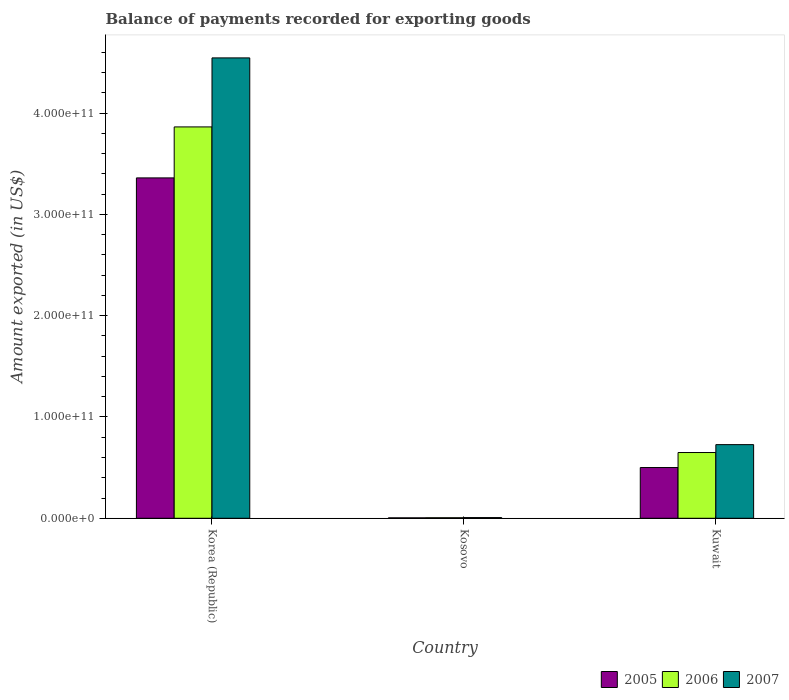Are the number of bars per tick equal to the number of legend labels?
Offer a very short reply. Yes. In how many cases, is the number of bars for a given country not equal to the number of legend labels?
Give a very brief answer. 0. What is the amount exported in 2005 in Korea (Republic)?
Offer a very short reply. 3.36e+11. Across all countries, what is the maximum amount exported in 2005?
Your response must be concise. 3.36e+11. Across all countries, what is the minimum amount exported in 2005?
Provide a short and direct response. 4.13e+08. In which country was the amount exported in 2005 maximum?
Provide a short and direct response. Korea (Republic). In which country was the amount exported in 2005 minimum?
Your answer should be very brief. Kosovo. What is the total amount exported in 2006 in the graph?
Offer a terse response. 4.52e+11. What is the difference between the amount exported in 2007 in Kosovo and that in Kuwait?
Your answer should be very brief. -7.20e+1. What is the difference between the amount exported in 2005 in Kosovo and the amount exported in 2007 in Korea (Republic)?
Make the answer very short. -4.54e+11. What is the average amount exported in 2005 per country?
Your response must be concise. 1.29e+11. What is the difference between the amount exported of/in 2005 and amount exported of/in 2006 in Korea (Republic)?
Keep it short and to the point. -5.03e+1. In how many countries, is the amount exported in 2007 greater than 120000000000 US$?
Provide a short and direct response. 1. What is the ratio of the amount exported in 2007 in Korea (Republic) to that in Kosovo?
Ensure brevity in your answer.  680.25. What is the difference between the highest and the second highest amount exported in 2005?
Your response must be concise. 2.86e+11. What is the difference between the highest and the lowest amount exported in 2007?
Make the answer very short. 4.54e+11. Is the sum of the amount exported in 2007 in Korea (Republic) and Kuwait greater than the maximum amount exported in 2005 across all countries?
Make the answer very short. Yes. What does the 1st bar from the left in Kosovo represents?
Offer a terse response. 2005. What does the 2nd bar from the right in Korea (Republic) represents?
Your response must be concise. 2006. Is it the case that in every country, the sum of the amount exported in 2006 and amount exported in 2005 is greater than the amount exported in 2007?
Keep it short and to the point. Yes. Are all the bars in the graph horizontal?
Offer a very short reply. No. What is the difference between two consecutive major ticks on the Y-axis?
Offer a terse response. 1.00e+11. Are the values on the major ticks of Y-axis written in scientific E-notation?
Keep it short and to the point. Yes. Does the graph contain any zero values?
Provide a succinct answer. No. Does the graph contain grids?
Your response must be concise. No. Where does the legend appear in the graph?
Offer a terse response. Bottom right. How many legend labels are there?
Ensure brevity in your answer.  3. How are the legend labels stacked?
Provide a short and direct response. Horizontal. What is the title of the graph?
Make the answer very short. Balance of payments recorded for exporting goods. Does "2013" appear as one of the legend labels in the graph?
Give a very brief answer. No. What is the label or title of the X-axis?
Offer a very short reply. Country. What is the label or title of the Y-axis?
Provide a succinct answer. Amount exported (in US$). What is the Amount exported (in US$) in 2005 in Korea (Republic)?
Offer a terse response. 3.36e+11. What is the Amount exported (in US$) in 2006 in Korea (Republic)?
Give a very brief answer. 3.86e+11. What is the Amount exported (in US$) in 2007 in Korea (Republic)?
Offer a very short reply. 4.54e+11. What is the Amount exported (in US$) of 2005 in Kosovo?
Your answer should be compact. 4.13e+08. What is the Amount exported (in US$) of 2006 in Kosovo?
Offer a very short reply. 5.15e+08. What is the Amount exported (in US$) of 2007 in Kosovo?
Make the answer very short. 6.68e+08. What is the Amount exported (in US$) of 2005 in Kuwait?
Offer a very short reply. 5.01e+1. What is the Amount exported (in US$) of 2006 in Kuwait?
Your answer should be very brief. 6.49e+1. What is the Amount exported (in US$) of 2007 in Kuwait?
Provide a short and direct response. 7.27e+1. Across all countries, what is the maximum Amount exported (in US$) in 2005?
Provide a succinct answer. 3.36e+11. Across all countries, what is the maximum Amount exported (in US$) in 2006?
Offer a very short reply. 3.86e+11. Across all countries, what is the maximum Amount exported (in US$) in 2007?
Provide a short and direct response. 4.54e+11. Across all countries, what is the minimum Amount exported (in US$) of 2005?
Make the answer very short. 4.13e+08. Across all countries, what is the minimum Amount exported (in US$) of 2006?
Your response must be concise. 5.15e+08. Across all countries, what is the minimum Amount exported (in US$) of 2007?
Give a very brief answer. 6.68e+08. What is the total Amount exported (in US$) of 2005 in the graph?
Your answer should be compact. 3.86e+11. What is the total Amount exported (in US$) of 2006 in the graph?
Your answer should be very brief. 4.52e+11. What is the total Amount exported (in US$) of 2007 in the graph?
Provide a short and direct response. 5.28e+11. What is the difference between the Amount exported (in US$) in 2005 in Korea (Republic) and that in Kosovo?
Give a very brief answer. 3.36e+11. What is the difference between the Amount exported (in US$) of 2006 in Korea (Republic) and that in Kosovo?
Make the answer very short. 3.86e+11. What is the difference between the Amount exported (in US$) of 2007 in Korea (Republic) and that in Kosovo?
Your answer should be compact. 4.54e+11. What is the difference between the Amount exported (in US$) in 2005 in Korea (Republic) and that in Kuwait?
Your answer should be very brief. 2.86e+11. What is the difference between the Amount exported (in US$) of 2006 in Korea (Republic) and that in Kuwait?
Provide a succinct answer. 3.21e+11. What is the difference between the Amount exported (in US$) of 2007 in Korea (Republic) and that in Kuwait?
Offer a terse response. 3.82e+11. What is the difference between the Amount exported (in US$) in 2005 in Kosovo and that in Kuwait?
Your answer should be compact. -4.97e+1. What is the difference between the Amount exported (in US$) of 2006 in Kosovo and that in Kuwait?
Make the answer very short. -6.44e+1. What is the difference between the Amount exported (in US$) of 2007 in Kosovo and that in Kuwait?
Your answer should be compact. -7.20e+1. What is the difference between the Amount exported (in US$) in 2005 in Korea (Republic) and the Amount exported (in US$) in 2006 in Kosovo?
Your response must be concise. 3.35e+11. What is the difference between the Amount exported (in US$) in 2005 in Korea (Republic) and the Amount exported (in US$) in 2007 in Kosovo?
Ensure brevity in your answer.  3.35e+11. What is the difference between the Amount exported (in US$) of 2006 in Korea (Republic) and the Amount exported (in US$) of 2007 in Kosovo?
Keep it short and to the point. 3.86e+11. What is the difference between the Amount exported (in US$) in 2005 in Korea (Republic) and the Amount exported (in US$) in 2006 in Kuwait?
Offer a very short reply. 2.71e+11. What is the difference between the Amount exported (in US$) in 2005 in Korea (Republic) and the Amount exported (in US$) in 2007 in Kuwait?
Keep it short and to the point. 2.63e+11. What is the difference between the Amount exported (in US$) of 2006 in Korea (Republic) and the Amount exported (in US$) of 2007 in Kuwait?
Provide a succinct answer. 3.14e+11. What is the difference between the Amount exported (in US$) in 2005 in Kosovo and the Amount exported (in US$) in 2006 in Kuwait?
Provide a short and direct response. -6.45e+1. What is the difference between the Amount exported (in US$) of 2005 in Kosovo and the Amount exported (in US$) of 2007 in Kuwait?
Offer a terse response. -7.23e+1. What is the difference between the Amount exported (in US$) of 2006 in Kosovo and the Amount exported (in US$) of 2007 in Kuwait?
Make the answer very short. -7.22e+1. What is the average Amount exported (in US$) in 2005 per country?
Provide a short and direct response. 1.29e+11. What is the average Amount exported (in US$) in 2006 per country?
Your answer should be very brief. 1.51e+11. What is the average Amount exported (in US$) in 2007 per country?
Make the answer very short. 1.76e+11. What is the difference between the Amount exported (in US$) in 2005 and Amount exported (in US$) in 2006 in Korea (Republic)?
Your answer should be compact. -5.03e+1. What is the difference between the Amount exported (in US$) of 2005 and Amount exported (in US$) of 2007 in Korea (Republic)?
Your response must be concise. -1.18e+11. What is the difference between the Amount exported (in US$) in 2006 and Amount exported (in US$) in 2007 in Korea (Republic)?
Provide a short and direct response. -6.81e+1. What is the difference between the Amount exported (in US$) of 2005 and Amount exported (in US$) of 2006 in Kosovo?
Provide a succinct answer. -1.02e+08. What is the difference between the Amount exported (in US$) of 2005 and Amount exported (in US$) of 2007 in Kosovo?
Provide a succinct answer. -2.55e+08. What is the difference between the Amount exported (in US$) in 2006 and Amount exported (in US$) in 2007 in Kosovo?
Your answer should be very brief. -1.53e+08. What is the difference between the Amount exported (in US$) in 2005 and Amount exported (in US$) in 2006 in Kuwait?
Your response must be concise. -1.48e+1. What is the difference between the Amount exported (in US$) in 2005 and Amount exported (in US$) in 2007 in Kuwait?
Give a very brief answer. -2.26e+1. What is the difference between the Amount exported (in US$) of 2006 and Amount exported (in US$) of 2007 in Kuwait?
Ensure brevity in your answer.  -7.80e+09. What is the ratio of the Amount exported (in US$) of 2005 in Korea (Republic) to that in Kosovo?
Ensure brevity in your answer.  813.87. What is the ratio of the Amount exported (in US$) in 2006 in Korea (Republic) to that in Kosovo?
Keep it short and to the point. 750.35. What is the ratio of the Amount exported (in US$) of 2007 in Korea (Republic) to that in Kosovo?
Provide a succinct answer. 680.25. What is the ratio of the Amount exported (in US$) of 2005 in Korea (Republic) to that in Kuwait?
Give a very brief answer. 6.71. What is the ratio of the Amount exported (in US$) of 2006 in Korea (Republic) to that in Kuwait?
Offer a terse response. 5.95. What is the ratio of the Amount exported (in US$) in 2007 in Korea (Republic) to that in Kuwait?
Your answer should be very brief. 6.25. What is the ratio of the Amount exported (in US$) in 2005 in Kosovo to that in Kuwait?
Give a very brief answer. 0.01. What is the ratio of the Amount exported (in US$) in 2006 in Kosovo to that in Kuwait?
Offer a terse response. 0.01. What is the ratio of the Amount exported (in US$) in 2007 in Kosovo to that in Kuwait?
Keep it short and to the point. 0.01. What is the difference between the highest and the second highest Amount exported (in US$) of 2005?
Offer a very short reply. 2.86e+11. What is the difference between the highest and the second highest Amount exported (in US$) in 2006?
Make the answer very short. 3.21e+11. What is the difference between the highest and the second highest Amount exported (in US$) in 2007?
Offer a very short reply. 3.82e+11. What is the difference between the highest and the lowest Amount exported (in US$) of 2005?
Make the answer very short. 3.36e+11. What is the difference between the highest and the lowest Amount exported (in US$) in 2006?
Keep it short and to the point. 3.86e+11. What is the difference between the highest and the lowest Amount exported (in US$) in 2007?
Ensure brevity in your answer.  4.54e+11. 